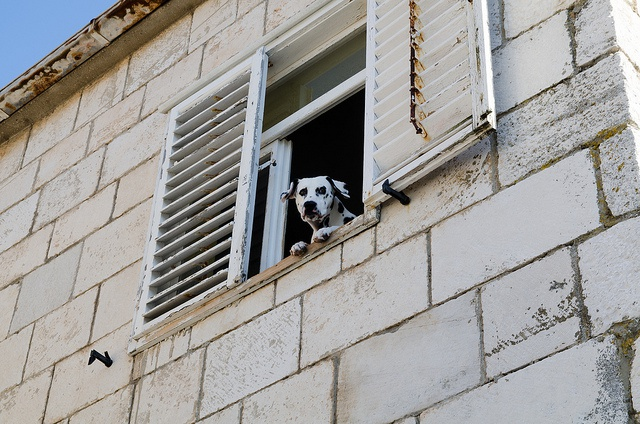Describe the objects in this image and their specific colors. I can see a dog in lightblue, black, darkgray, and gray tones in this image. 